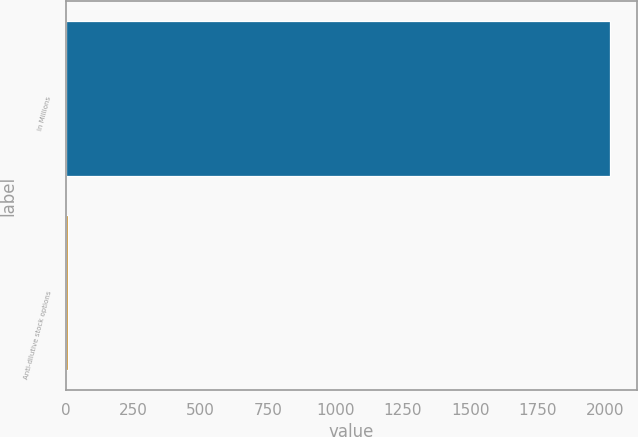Convert chart. <chart><loc_0><loc_0><loc_500><loc_500><bar_chart><fcel>In Millions<fcel>Anti-dilutive stock options<nl><fcel>2018<fcel>8.9<nl></chart> 